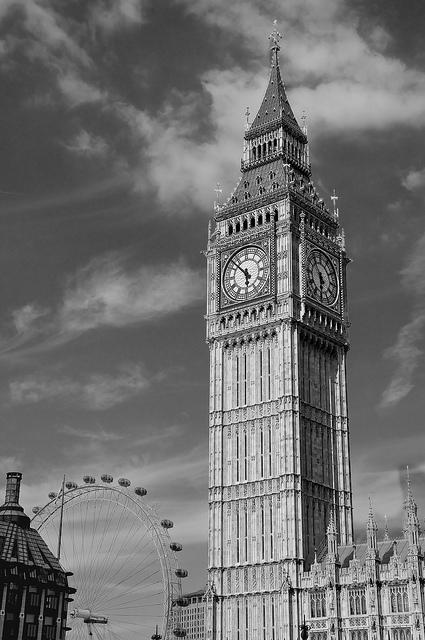Is there a ferris wheel in the photo?
Short answer required. Yes. What time is it?
Answer briefly. 5:50. Is there a clock on the tower?
Write a very short answer. Yes. Is the tower beautiful?
Answer briefly. Yes. What city is this photo?
Concise answer only. London. 